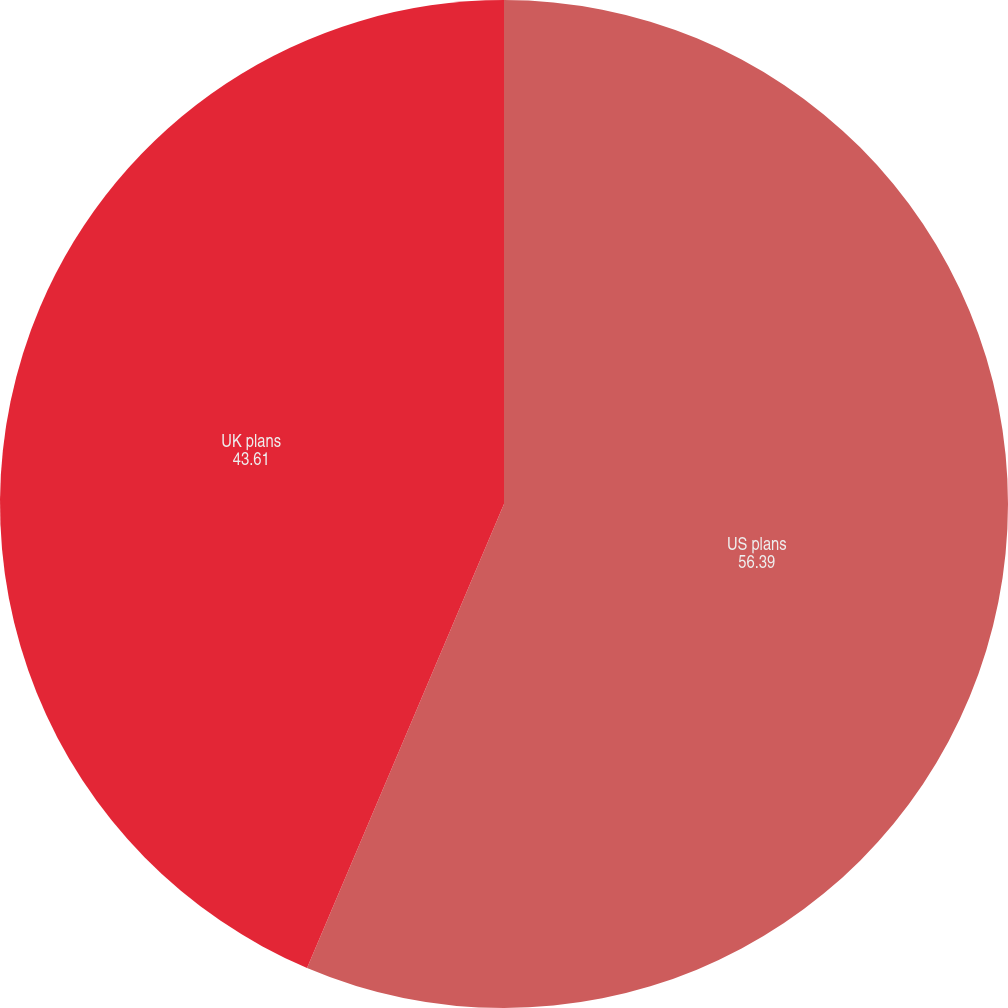<chart> <loc_0><loc_0><loc_500><loc_500><pie_chart><fcel>US plans<fcel>UK plans<nl><fcel>56.39%<fcel>43.61%<nl></chart> 